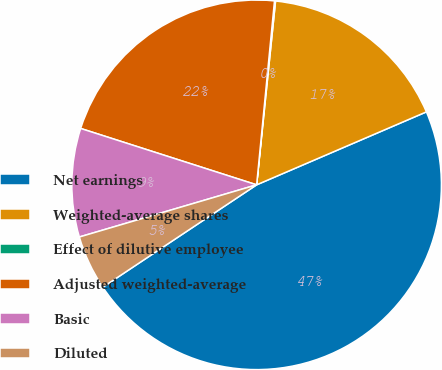Convert chart to OTSL. <chart><loc_0><loc_0><loc_500><loc_500><pie_chart><fcel>Net earnings<fcel>Weighted-average shares<fcel>Effect of dilutive employee<fcel>Adjusted weighted-average<fcel>Basic<fcel>Diluted<nl><fcel>47.12%<fcel>16.91%<fcel>0.09%<fcel>21.61%<fcel>9.49%<fcel>4.79%<nl></chart> 